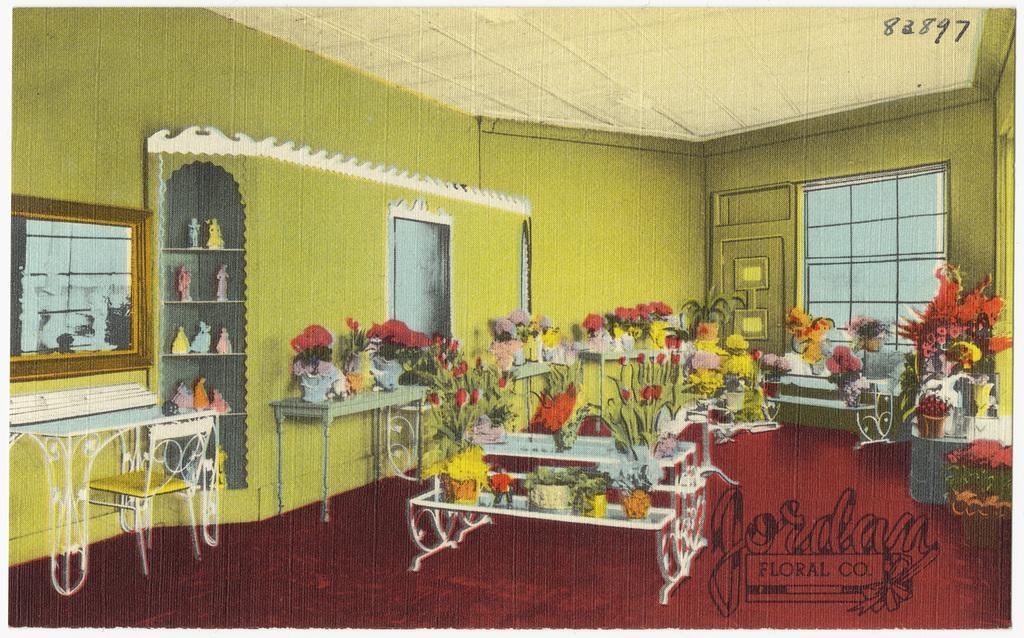Describe this image in one or two sentences. In this image I can see there is a poster and there are few plants placed on the table and there is a watermark on the image. There is a table and a chair at left side and there are few windows. 